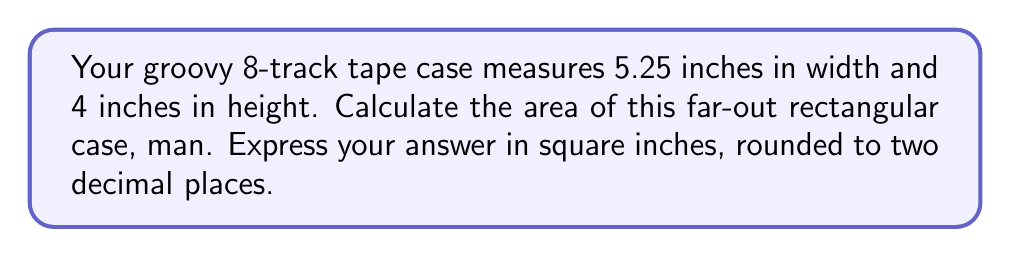Provide a solution to this math problem. Alright, let's break it down, cool cat:

1) We're dealing with a rectangular shape here, so we'll use the formula for the area of a rectangle:

   $$A = w \times h$$

   Where $A$ is the area, $w$ is the width, and $h$ is the height.

2) We've got the measurements:
   - Width ($w$) = 5.25 inches
   - Height ($h$) = 4 inches

3) Let's plug these groovy numbers into our formula:

   $$A = 5.25 \times 4$$

4) Now, let's multiply:

   $$A = 21$$

5) Our result is in square inches, and it's already a whole number, so no need to round.

[asy]
unitsize(0.5cm);
draw((0,0)--(5.25,0)--(5.25,4)--(0,4)--cycle);
label("5.25\"", (2.625,-0.5));
label("4\"", (5.75,2), E);
label("Area = 21 sq in", (2.625,2));
[/asy]
Answer: 21 sq in 